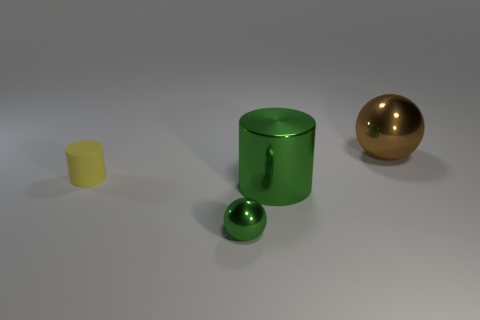Add 3 large green shiny cylinders. How many objects exist? 7 Add 2 small green objects. How many small green objects are left? 3 Add 2 large yellow cylinders. How many large yellow cylinders exist? 2 Subtract 0 yellow spheres. How many objects are left? 4 Subtract all matte cylinders. Subtract all big cylinders. How many objects are left? 2 